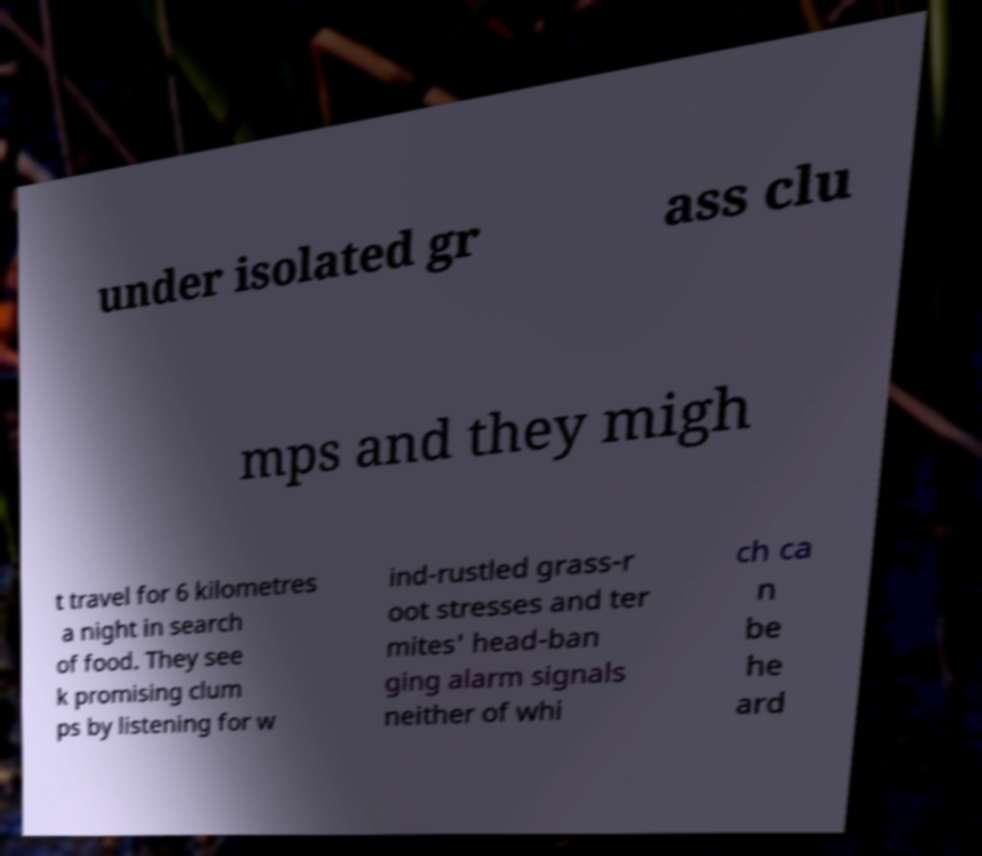Please identify and transcribe the text found in this image. under isolated gr ass clu mps and they migh t travel for 6 kilometres a night in search of food. They see k promising clum ps by listening for w ind-rustled grass-r oot stresses and ter mites' head-ban ging alarm signals neither of whi ch ca n be he ard 